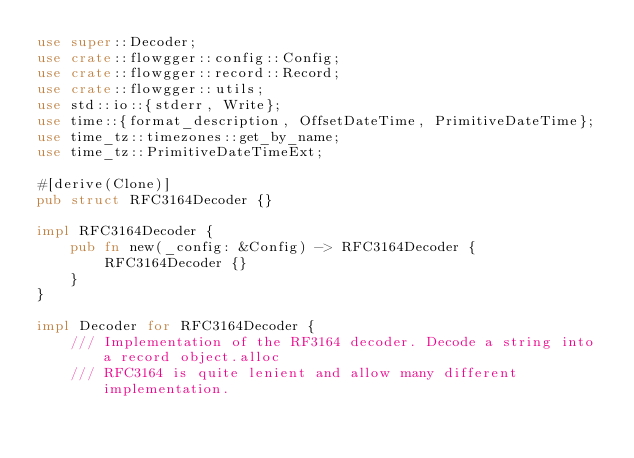<code> <loc_0><loc_0><loc_500><loc_500><_Rust_>use super::Decoder;
use crate::flowgger::config::Config;
use crate::flowgger::record::Record;
use crate::flowgger::utils;
use std::io::{stderr, Write};
use time::{format_description, OffsetDateTime, PrimitiveDateTime};
use time_tz::timezones::get_by_name;
use time_tz::PrimitiveDateTimeExt;

#[derive(Clone)]
pub struct RFC3164Decoder {}

impl RFC3164Decoder {
    pub fn new(_config: &Config) -> RFC3164Decoder {
        RFC3164Decoder {}
    }
}

impl Decoder for RFC3164Decoder {
    /// Implementation of the RF3164 decoder. Decode a string into a record object.alloc
    /// RFC3164 is quite lenient and allow many different implementation.</code> 